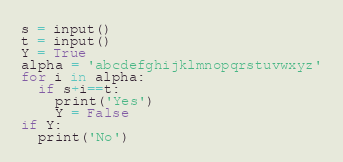Convert code to text. <code><loc_0><loc_0><loc_500><loc_500><_Python_>s = input()
t = input()
Y = True
alpha = 'abcdefghijklmnopqrstuvwxyz'
for i in alpha:
  if s+i==t:
    print('Yes')
    Y = False
if Y:
  print('No')</code> 